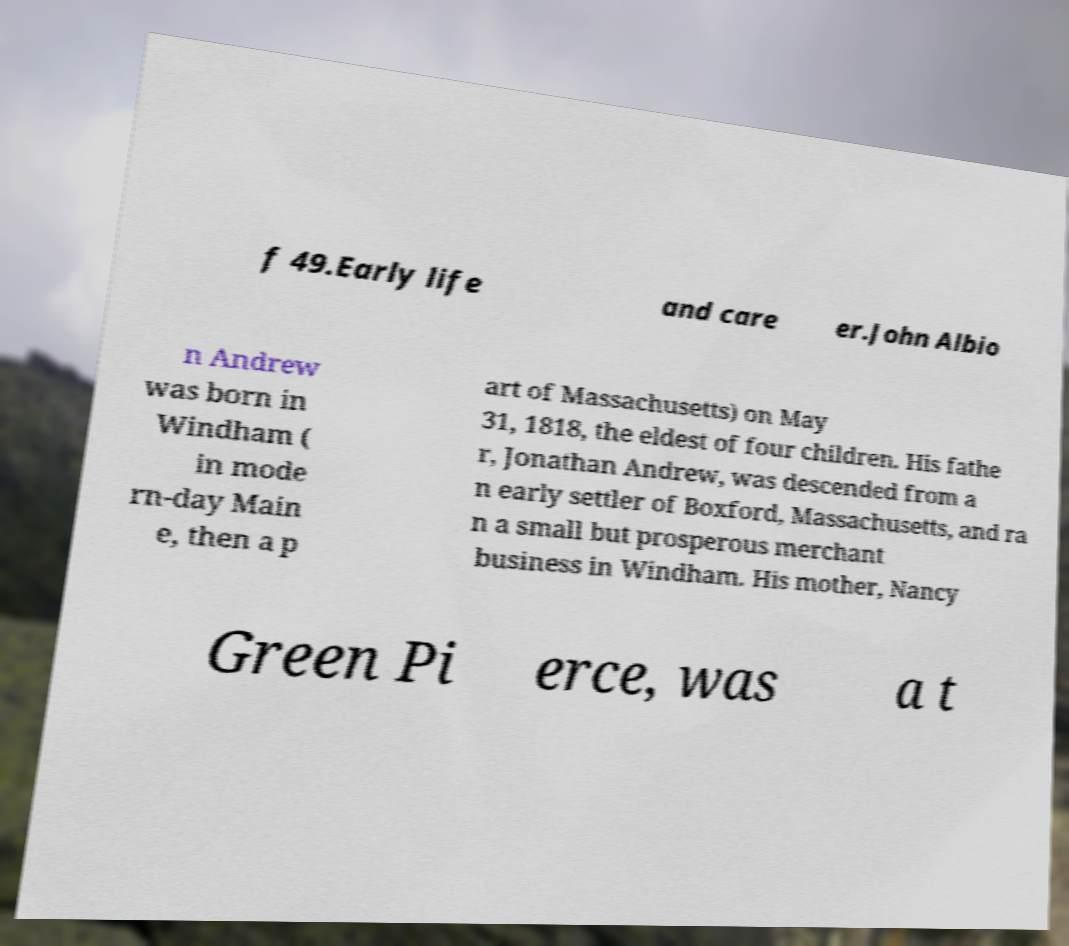Can you accurately transcribe the text from the provided image for me? f 49.Early life and care er.John Albio n Andrew was born in Windham ( in mode rn-day Main e, then a p art of Massachusetts) on May 31, 1818, the eldest of four children. His fathe r, Jonathan Andrew, was descended from a n early settler of Boxford, Massachusetts, and ra n a small but prosperous merchant business in Windham. His mother, Nancy Green Pi erce, was a t 